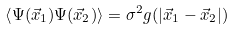<formula> <loc_0><loc_0><loc_500><loc_500>\left < \Psi ( \vec { x } _ { 1 } ) \Psi ( \vec { x } _ { 2 } ) \right > = \sigma ^ { 2 } g ( | \vec { x } _ { 1 } - \vec { x } _ { 2 } | )</formula> 